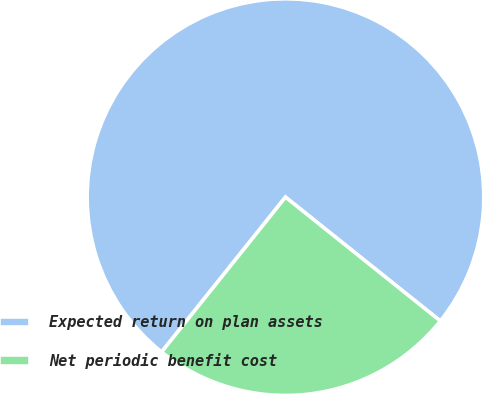<chart> <loc_0><loc_0><loc_500><loc_500><pie_chart><fcel>Expected return on plan assets<fcel>Net periodic benefit cost<nl><fcel>75.0%<fcel>25.0%<nl></chart> 